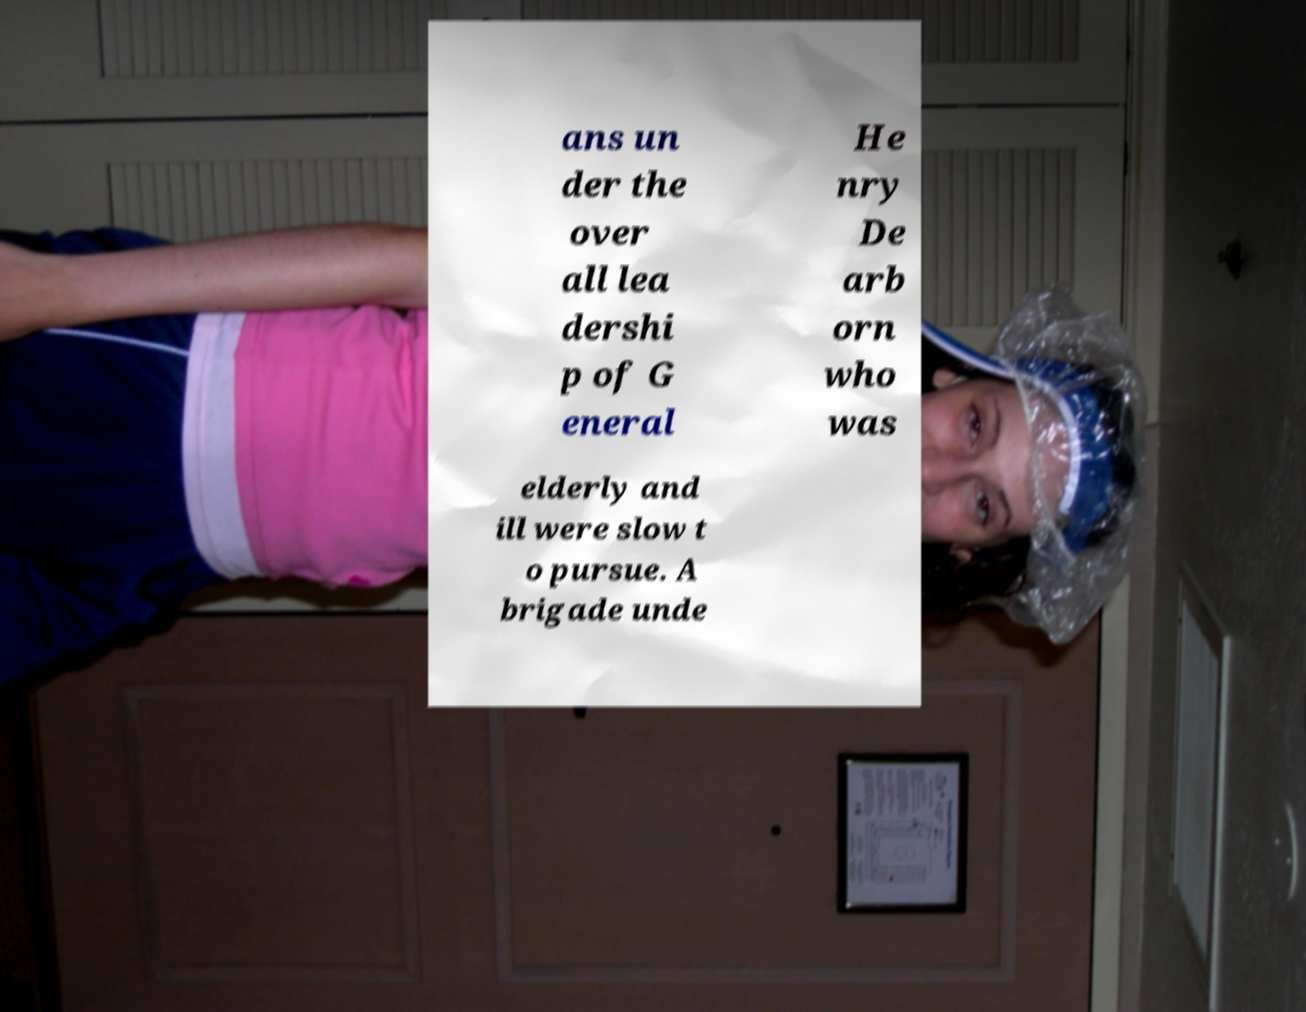Could you assist in decoding the text presented in this image and type it out clearly? ans un der the over all lea dershi p of G eneral He nry De arb orn who was elderly and ill were slow t o pursue. A brigade unde 